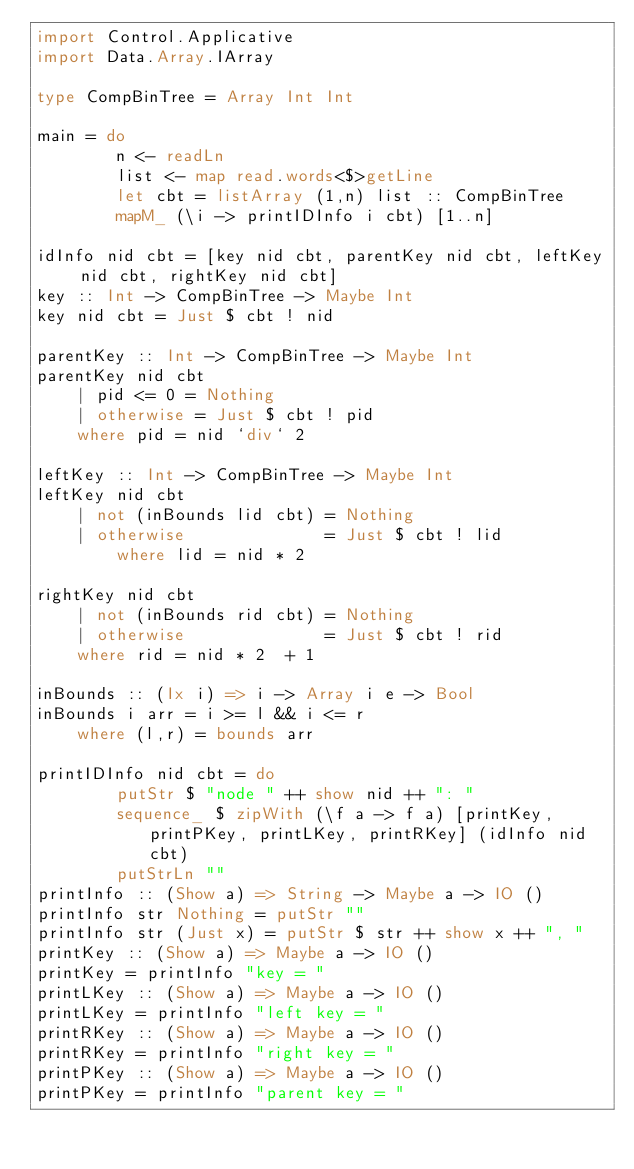Convert code to text. <code><loc_0><loc_0><loc_500><loc_500><_Haskell_>import Control.Applicative
import Data.Array.IArray

type CompBinTree = Array Int Int

main = do
        n <- readLn
        list <- map read.words<$>getLine
        let cbt = listArray (1,n) list :: CompBinTree
        mapM_ (\i -> printIDInfo i cbt) [1..n]

idInfo nid cbt = [key nid cbt, parentKey nid cbt, leftKey nid cbt, rightKey nid cbt]
key :: Int -> CompBinTree -> Maybe Int
key nid cbt = Just $ cbt ! nid

parentKey :: Int -> CompBinTree -> Maybe Int
parentKey nid cbt
    | pid <= 0 = Nothing
    | otherwise = Just $ cbt ! pid
    where pid = nid `div` 2

leftKey :: Int -> CompBinTree -> Maybe Int
leftKey nid cbt
    | not (inBounds lid cbt) = Nothing
    | otherwise              = Just $ cbt ! lid
        where lid = nid * 2

rightKey nid cbt
    | not (inBounds rid cbt) = Nothing
    | otherwise              = Just $ cbt ! rid
    where rid = nid * 2  + 1

inBounds :: (Ix i) => i -> Array i e -> Bool
inBounds i arr = i >= l && i <= r
    where (l,r) = bounds arr

printIDInfo nid cbt = do
        putStr $ "node " ++ show nid ++ ": "
        sequence_ $ zipWith (\f a -> f a) [printKey, printPKey, printLKey, printRKey] (idInfo nid cbt)
        putStrLn ""
printInfo :: (Show a) => String -> Maybe a -> IO ()
printInfo str Nothing = putStr ""
printInfo str (Just x) = putStr $ str ++ show x ++ ", "
printKey :: (Show a) => Maybe a -> IO ()
printKey = printInfo "key = "
printLKey :: (Show a) => Maybe a -> IO ()
printLKey = printInfo "left key = "
printRKey :: (Show a) => Maybe a -> IO ()
printRKey = printInfo "right key = "
printPKey :: (Show a) => Maybe a -> IO ()
printPKey = printInfo "parent key = "</code> 